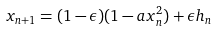<formula> <loc_0><loc_0><loc_500><loc_500>x _ { n + 1 } = ( 1 - \epsilon ) ( 1 - a x _ { n } ^ { 2 } ) + \epsilon h _ { n }</formula> 